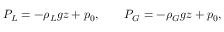<formula> <loc_0><loc_0><loc_500><loc_500>P _ { L } = - \rho _ { L } g z + p _ { 0 } , \quad P _ { G } = - \rho _ { G } g z + p _ { 0 } ,</formula> 